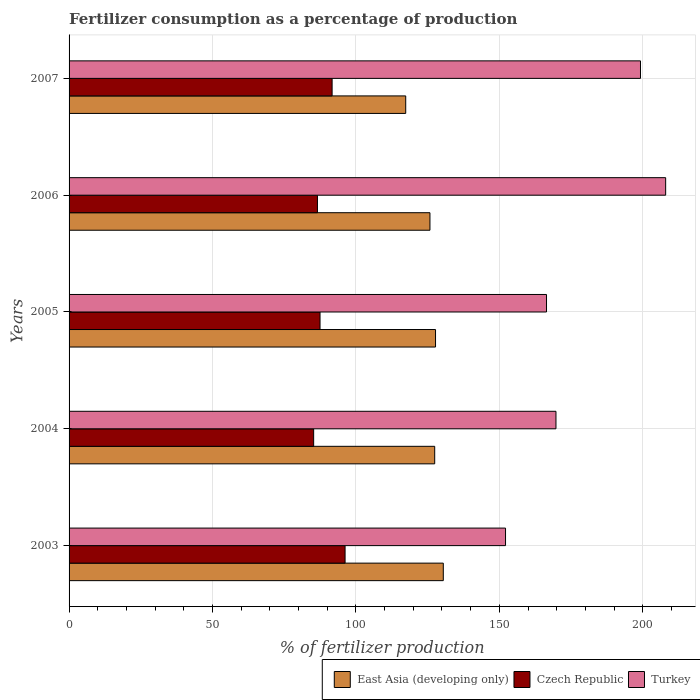How many groups of bars are there?
Give a very brief answer. 5. Are the number of bars per tick equal to the number of legend labels?
Your answer should be compact. Yes. How many bars are there on the 4th tick from the bottom?
Your response must be concise. 3. In how many cases, is the number of bars for a given year not equal to the number of legend labels?
Offer a terse response. 0. What is the percentage of fertilizers consumed in Czech Republic in 2007?
Your response must be concise. 91.7. Across all years, what is the maximum percentage of fertilizers consumed in East Asia (developing only)?
Your answer should be very brief. 130.46. Across all years, what is the minimum percentage of fertilizers consumed in Czech Republic?
Your answer should be compact. 85.27. In which year was the percentage of fertilizers consumed in Turkey maximum?
Keep it short and to the point. 2006. In which year was the percentage of fertilizers consumed in East Asia (developing only) minimum?
Keep it short and to the point. 2007. What is the total percentage of fertilizers consumed in East Asia (developing only) in the graph?
Ensure brevity in your answer.  628.87. What is the difference between the percentage of fertilizers consumed in Turkey in 2005 and that in 2007?
Ensure brevity in your answer.  -32.76. What is the difference between the percentage of fertilizers consumed in Czech Republic in 2005 and the percentage of fertilizers consumed in Turkey in 2003?
Make the answer very short. -64.67. What is the average percentage of fertilizers consumed in Turkey per year?
Provide a short and direct response. 179.11. In the year 2007, what is the difference between the percentage of fertilizers consumed in Czech Republic and percentage of fertilizers consumed in Turkey?
Keep it short and to the point. -107.5. What is the ratio of the percentage of fertilizers consumed in Czech Republic in 2003 to that in 2004?
Provide a succinct answer. 1.13. Is the percentage of fertilizers consumed in Czech Republic in 2004 less than that in 2007?
Keep it short and to the point. Yes. What is the difference between the highest and the second highest percentage of fertilizers consumed in Czech Republic?
Provide a succinct answer. 4.52. What is the difference between the highest and the lowest percentage of fertilizers consumed in Turkey?
Keep it short and to the point. 55.83. Is the sum of the percentage of fertilizers consumed in East Asia (developing only) in 2003 and 2004 greater than the maximum percentage of fertilizers consumed in Turkey across all years?
Make the answer very short. Yes. What does the 2nd bar from the top in 2004 represents?
Ensure brevity in your answer.  Czech Republic. What does the 1st bar from the bottom in 2004 represents?
Offer a terse response. East Asia (developing only). What is the difference between two consecutive major ticks on the X-axis?
Provide a short and direct response. 50. Does the graph contain any zero values?
Your answer should be compact. No. Does the graph contain grids?
Offer a terse response. Yes. Where does the legend appear in the graph?
Your response must be concise. Bottom right. How many legend labels are there?
Offer a very short reply. 3. How are the legend labels stacked?
Make the answer very short. Horizontal. What is the title of the graph?
Provide a short and direct response. Fertilizer consumption as a percentage of production. Does "Macao" appear as one of the legend labels in the graph?
Offer a terse response. No. What is the label or title of the X-axis?
Offer a terse response. % of fertilizer production. What is the % of fertilizer production of East Asia (developing only) in 2003?
Your answer should be very brief. 130.46. What is the % of fertilizer production in Czech Republic in 2003?
Keep it short and to the point. 96.22. What is the % of fertilizer production in Turkey in 2003?
Your answer should be very brief. 152.16. What is the % of fertilizer production of East Asia (developing only) in 2004?
Give a very brief answer. 127.47. What is the % of fertilizer production of Czech Republic in 2004?
Your answer should be very brief. 85.27. What is the % of fertilizer production of Turkey in 2004?
Ensure brevity in your answer.  169.74. What is the % of fertilizer production in East Asia (developing only) in 2005?
Your answer should be compact. 127.76. What is the % of fertilizer production of Czech Republic in 2005?
Make the answer very short. 87.49. What is the % of fertilizer production of Turkey in 2005?
Offer a terse response. 166.45. What is the % of fertilizer production of East Asia (developing only) in 2006?
Your answer should be compact. 125.81. What is the % of fertilizer production in Czech Republic in 2006?
Provide a succinct answer. 86.59. What is the % of fertilizer production of Turkey in 2006?
Keep it short and to the point. 207.99. What is the % of fertilizer production of East Asia (developing only) in 2007?
Ensure brevity in your answer.  117.36. What is the % of fertilizer production in Czech Republic in 2007?
Your response must be concise. 91.7. What is the % of fertilizer production of Turkey in 2007?
Offer a terse response. 199.21. Across all years, what is the maximum % of fertilizer production of East Asia (developing only)?
Your answer should be compact. 130.46. Across all years, what is the maximum % of fertilizer production of Czech Republic?
Give a very brief answer. 96.22. Across all years, what is the maximum % of fertilizer production in Turkey?
Make the answer very short. 207.99. Across all years, what is the minimum % of fertilizer production in East Asia (developing only)?
Offer a very short reply. 117.36. Across all years, what is the minimum % of fertilizer production of Czech Republic?
Keep it short and to the point. 85.27. Across all years, what is the minimum % of fertilizer production in Turkey?
Ensure brevity in your answer.  152.16. What is the total % of fertilizer production of East Asia (developing only) in the graph?
Provide a short and direct response. 628.87. What is the total % of fertilizer production of Czech Republic in the graph?
Your answer should be compact. 447.28. What is the total % of fertilizer production in Turkey in the graph?
Provide a short and direct response. 895.54. What is the difference between the % of fertilizer production of East Asia (developing only) in 2003 and that in 2004?
Your response must be concise. 3. What is the difference between the % of fertilizer production in Czech Republic in 2003 and that in 2004?
Ensure brevity in your answer.  10.95. What is the difference between the % of fertilizer production in Turkey in 2003 and that in 2004?
Offer a terse response. -17.58. What is the difference between the % of fertilizer production of East Asia (developing only) in 2003 and that in 2005?
Offer a very short reply. 2.71. What is the difference between the % of fertilizer production in Czech Republic in 2003 and that in 2005?
Your answer should be very brief. 8.73. What is the difference between the % of fertilizer production in Turkey in 2003 and that in 2005?
Your response must be concise. -14.29. What is the difference between the % of fertilizer production in East Asia (developing only) in 2003 and that in 2006?
Provide a short and direct response. 4.65. What is the difference between the % of fertilizer production in Czech Republic in 2003 and that in 2006?
Your answer should be very brief. 9.63. What is the difference between the % of fertilizer production of Turkey in 2003 and that in 2006?
Ensure brevity in your answer.  -55.83. What is the difference between the % of fertilizer production of East Asia (developing only) in 2003 and that in 2007?
Your answer should be compact. 13.1. What is the difference between the % of fertilizer production of Czech Republic in 2003 and that in 2007?
Keep it short and to the point. 4.52. What is the difference between the % of fertilizer production of Turkey in 2003 and that in 2007?
Provide a succinct answer. -47.05. What is the difference between the % of fertilizer production in East Asia (developing only) in 2004 and that in 2005?
Provide a short and direct response. -0.29. What is the difference between the % of fertilizer production in Czech Republic in 2004 and that in 2005?
Keep it short and to the point. -2.22. What is the difference between the % of fertilizer production of Turkey in 2004 and that in 2005?
Provide a short and direct response. 3.29. What is the difference between the % of fertilizer production in East Asia (developing only) in 2004 and that in 2006?
Your answer should be compact. 1.65. What is the difference between the % of fertilizer production of Czech Republic in 2004 and that in 2006?
Keep it short and to the point. -1.33. What is the difference between the % of fertilizer production of Turkey in 2004 and that in 2006?
Give a very brief answer. -38.24. What is the difference between the % of fertilizer production of East Asia (developing only) in 2004 and that in 2007?
Offer a very short reply. 10.11. What is the difference between the % of fertilizer production in Czech Republic in 2004 and that in 2007?
Your answer should be very brief. -6.43. What is the difference between the % of fertilizer production of Turkey in 2004 and that in 2007?
Provide a succinct answer. -29.46. What is the difference between the % of fertilizer production in East Asia (developing only) in 2005 and that in 2006?
Ensure brevity in your answer.  1.94. What is the difference between the % of fertilizer production in Czech Republic in 2005 and that in 2006?
Give a very brief answer. 0.9. What is the difference between the % of fertilizer production in Turkey in 2005 and that in 2006?
Offer a very short reply. -41.54. What is the difference between the % of fertilizer production in East Asia (developing only) in 2005 and that in 2007?
Make the answer very short. 10.39. What is the difference between the % of fertilizer production in Czech Republic in 2005 and that in 2007?
Your response must be concise. -4.21. What is the difference between the % of fertilizer production in Turkey in 2005 and that in 2007?
Make the answer very short. -32.76. What is the difference between the % of fertilizer production of East Asia (developing only) in 2006 and that in 2007?
Offer a very short reply. 8.45. What is the difference between the % of fertilizer production of Czech Republic in 2006 and that in 2007?
Your response must be concise. -5.11. What is the difference between the % of fertilizer production in Turkey in 2006 and that in 2007?
Provide a short and direct response. 8.78. What is the difference between the % of fertilizer production in East Asia (developing only) in 2003 and the % of fertilizer production in Czech Republic in 2004?
Provide a short and direct response. 45.2. What is the difference between the % of fertilizer production in East Asia (developing only) in 2003 and the % of fertilizer production in Turkey in 2004?
Provide a succinct answer. -39.28. What is the difference between the % of fertilizer production in Czech Republic in 2003 and the % of fertilizer production in Turkey in 2004?
Make the answer very short. -73.52. What is the difference between the % of fertilizer production in East Asia (developing only) in 2003 and the % of fertilizer production in Czech Republic in 2005?
Your response must be concise. 42.97. What is the difference between the % of fertilizer production in East Asia (developing only) in 2003 and the % of fertilizer production in Turkey in 2005?
Offer a terse response. -35.98. What is the difference between the % of fertilizer production in Czech Republic in 2003 and the % of fertilizer production in Turkey in 2005?
Your response must be concise. -70.23. What is the difference between the % of fertilizer production of East Asia (developing only) in 2003 and the % of fertilizer production of Czech Republic in 2006?
Make the answer very short. 43.87. What is the difference between the % of fertilizer production in East Asia (developing only) in 2003 and the % of fertilizer production in Turkey in 2006?
Offer a very short reply. -77.52. What is the difference between the % of fertilizer production of Czech Republic in 2003 and the % of fertilizer production of Turkey in 2006?
Your answer should be compact. -111.76. What is the difference between the % of fertilizer production in East Asia (developing only) in 2003 and the % of fertilizer production in Czech Republic in 2007?
Your answer should be very brief. 38.76. What is the difference between the % of fertilizer production in East Asia (developing only) in 2003 and the % of fertilizer production in Turkey in 2007?
Offer a terse response. -68.74. What is the difference between the % of fertilizer production of Czech Republic in 2003 and the % of fertilizer production of Turkey in 2007?
Ensure brevity in your answer.  -102.98. What is the difference between the % of fertilizer production in East Asia (developing only) in 2004 and the % of fertilizer production in Czech Republic in 2005?
Your response must be concise. 39.98. What is the difference between the % of fertilizer production in East Asia (developing only) in 2004 and the % of fertilizer production in Turkey in 2005?
Offer a very short reply. -38.98. What is the difference between the % of fertilizer production in Czech Republic in 2004 and the % of fertilizer production in Turkey in 2005?
Your answer should be compact. -81.18. What is the difference between the % of fertilizer production of East Asia (developing only) in 2004 and the % of fertilizer production of Czech Republic in 2006?
Ensure brevity in your answer.  40.88. What is the difference between the % of fertilizer production of East Asia (developing only) in 2004 and the % of fertilizer production of Turkey in 2006?
Make the answer very short. -80.52. What is the difference between the % of fertilizer production in Czech Republic in 2004 and the % of fertilizer production in Turkey in 2006?
Ensure brevity in your answer.  -122.72. What is the difference between the % of fertilizer production of East Asia (developing only) in 2004 and the % of fertilizer production of Czech Republic in 2007?
Make the answer very short. 35.77. What is the difference between the % of fertilizer production in East Asia (developing only) in 2004 and the % of fertilizer production in Turkey in 2007?
Your answer should be compact. -71.74. What is the difference between the % of fertilizer production of Czech Republic in 2004 and the % of fertilizer production of Turkey in 2007?
Your response must be concise. -113.94. What is the difference between the % of fertilizer production of East Asia (developing only) in 2005 and the % of fertilizer production of Czech Republic in 2006?
Give a very brief answer. 41.16. What is the difference between the % of fertilizer production of East Asia (developing only) in 2005 and the % of fertilizer production of Turkey in 2006?
Your response must be concise. -80.23. What is the difference between the % of fertilizer production in Czech Republic in 2005 and the % of fertilizer production in Turkey in 2006?
Offer a terse response. -120.49. What is the difference between the % of fertilizer production in East Asia (developing only) in 2005 and the % of fertilizer production in Czech Republic in 2007?
Make the answer very short. 36.05. What is the difference between the % of fertilizer production of East Asia (developing only) in 2005 and the % of fertilizer production of Turkey in 2007?
Provide a succinct answer. -71.45. What is the difference between the % of fertilizer production in Czech Republic in 2005 and the % of fertilizer production in Turkey in 2007?
Provide a succinct answer. -111.71. What is the difference between the % of fertilizer production of East Asia (developing only) in 2006 and the % of fertilizer production of Czech Republic in 2007?
Provide a short and direct response. 34.11. What is the difference between the % of fertilizer production in East Asia (developing only) in 2006 and the % of fertilizer production in Turkey in 2007?
Offer a terse response. -73.39. What is the difference between the % of fertilizer production of Czech Republic in 2006 and the % of fertilizer production of Turkey in 2007?
Offer a very short reply. -112.61. What is the average % of fertilizer production in East Asia (developing only) per year?
Provide a short and direct response. 125.77. What is the average % of fertilizer production in Czech Republic per year?
Ensure brevity in your answer.  89.46. What is the average % of fertilizer production in Turkey per year?
Your answer should be compact. 179.11. In the year 2003, what is the difference between the % of fertilizer production of East Asia (developing only) and % of fertilizer production of Czech Republic?
Make the answer very short. 34.24. In the year 2003, what is the difference between the % of fertilizer production of East Asia (developing only) and % of fertilizer production of Turkey?
Your answer should be compact. -21.7. In the year 2003, what is the difference between the % of fertilizer production of Czech Republic and % of fertilizer production of Turkey?
Your response must be concise. -55.94. In the year 2004, what is the difference between the % of fertilizer production of East Asia (developing only) and % of fertilizer production of Czech Republic?
Provide a short and direct response. 42.2. In the year 2004, what is the difference between the % of fertilizer production of East Asia (developing only) and % of fertilizer production of Turkey?
Provide a succinct answer. -42.27. In the year 2004, what is the difference between the % of fertilizer production of Czech Republic and % of fertilizer production of Turkey?
Your answer should be compact. -84.47. In the year 2005, what is the difference between the % of fertilizer production in East Asia (developing only) and % of fertilizer production in Czech Republic?
Ensure brevity in your answer.  40.27. In the year 2005, what is the difference between the % of fertilizer production in East Asia (developing only) and % of fertilizer production in Turkey?
Offer a terse response. -38.69. In the year 2005, what is the difference between the % of fertilizer production in Czech Republic and % of fertilizer production in Turkey?
Your response must be concise. -78.96. In the year 2006, what is the difference between the % of fertilizer production in East Asia (developing only) and % of fertilizer production in Czech Republic?
Offer a terse response. 39.22. In the year 2006, what is the difference between the % of fertilizer production of East Asia (developing only) and % of fertilizer production of Turkey?
Provide a short and direct response. -82.17. In the year 2006, what is the difference between the % of fertilizer production in Czech Republic and % of fertilizer production in Turkey?
Ensure brevity in your answer.  -121.39. In the year 2007, what is the difference between the % of fertilizer production in East Asia (developing only) and % of fertilizer production in Czech Republic?
Make the answer very short. 25.66. In the year 2007, what is the difference between the % of fertilizer production in East Asia (developing only) and % of fertilizer production in Turkey?
Give a very brief answer. -81.84. In the year 2007, what is the difference between the % of fertilizer production in Czech Republic and % of fertilizer production in Turkey?
Provide a short and direct response. -107.5. What is the ratio of the % of fertilizer production of East Asia (developing only) in 2003 to that in 2004?
Give a very brief answer. 1.02. What is the ratio of the % of fertilizer production of Czech Republic in 2003 to that in 2004?
Your answer should be very brief. 1.13. What is the ratio of the % of fertilizer production of Turkey in 2003 to that in 2004?
Make the answer very short. 0.9. What is the ratio of the % of fertilizer production of East Asia (developing only) in 2003 to that in 2005?
Keep it short and to the point. 1.02. What is the ratio of the % of fertilizer production in Czech Republic in 2003 to that in 2005?
Make the answer very short. 1.1. What is the ratio of the % of fertilizer production in Turkey in 2003 to that in 2005?
Your answer should be very brief. 0.91. What is the ratio of the % of fertilizer production of East Asia (developing only) in 2003 to that in 2006?
Your answer should be very brief. 1.04. What is the ratio of the % of fertilizer production in Czech Republic in 2003 to that in 2006?
Offer a terse response. 1.11. What is the ratio of the % of fertilizer production of Turkey in 2003 to that in 2006?
Offer a terse response. 0.73. What is the ratio of the % of fertilizer production of East Asia (developing only) in 2003 to that in 2007?
Ensure brevity in your answer.  1.11. What is the ratio of the % of fertilizer production of Czech Republic in 2003 to that in 2007?
Keep it short and to the point. 1.05. What is the ratio of the % of fertilizer production in Turkey in 2003 to that in 2007?
Your answer should be compact. 0.76. What is the ratio of the % of fertilizer production in Czech Republic in 2004 to that in 2005?
Your response must be concise. 0.97. What is the ratio of the % of fertilizer production of Turkey in 2004 to that in 2005?
Ensure brevity in your answer.  1.02. What is the ratio of the % of fertilizer production of East Asia (developing only) in 2004 to that in 2006?
Your answer should be very brief. 1.01. What is the ratio of the % of fertilizer production in Czech Republic in 2004 to that in 2006?
Offer a terse response. 0.98. What is the ratio of the % of fertilizer production in Turkey in 2004 to that in 2006?
Your answer should be compact. 0.82. What is the ratio of the % of fertilizer production in East Asia (developing only) in 2004 to that in 2007?
Provide a short and direct response. 1.09. What is the ratio of the % of fertilizer production of Czech Republic in 2004 to that in 2007?
Your response must be concise. 0.93. What is the ratio of the % of fertilizer production of Turkey in 2004 to that in 2007?
Offer a very short reply. 0.85. What is the ratio of the % of fertilizer production in East Asia (developing only) in 2005 to that in 2006?
Your answer should be compact. 1.02. What is the ratio of the % of fertilizer production in Czech Republic in 2005 to that in 2006?
Offer a very short reply. 1.01. What is the ratio of the % of fertilizer production of Turkey in 2005 to that in 2006?
Offer a very short reply. 0.8. What is the ratio of the % of fertilizer production in East Asia (developing only) in 2005 to that in 2007?
Make the answer very short. 1.09. What is the ratio of the % of fertilizer production of Czech Republic in 2005 to that in 2007?
Give a very brief answer. 0.95. What is the ratio of the % of fertilizer production in Turkey in 2005 to that in 2007?
Your answer should be compact. 0.84. What is the ratio of the % of fertilizer production in East Asia (developing only) in 2006 to that in 2007?
Your answer should be very brief. 1.07. What is the ratio of the % of fertilizer production of Czech Republic in 2006 to that in 2007?
Your answer should be compact. 0.94. What is the ratio of the % of fertilizer production in Turkey in 2006 to that in 2007?
Keep it short and to the point. 1.04. What is the difference between the highest and the second highest % of fertilizer production of East Asia (developing only)?
Your answer should be very brief. 2.71. What is the difference between the highest and the second highest % of fertilizer production in Czech Republic?
Offer a very short reply. 4.52. What is the difference between the highest and the second highest % of fertilizer production of Turkey?
Offer a very short reply. 8.78. What is the difference between the highest and the lowest % of fertilizer production in East Asia (developing only)?
Your response must be concise. 13.1. What is the difference between the highest and the lowest % of fertilizer production in Czech Republic?
Offer a terse response. 10.95. What is the difference between the highest and the lowest % of fertilizer production in Turkey?
Give a very brief answer. 55.83. 